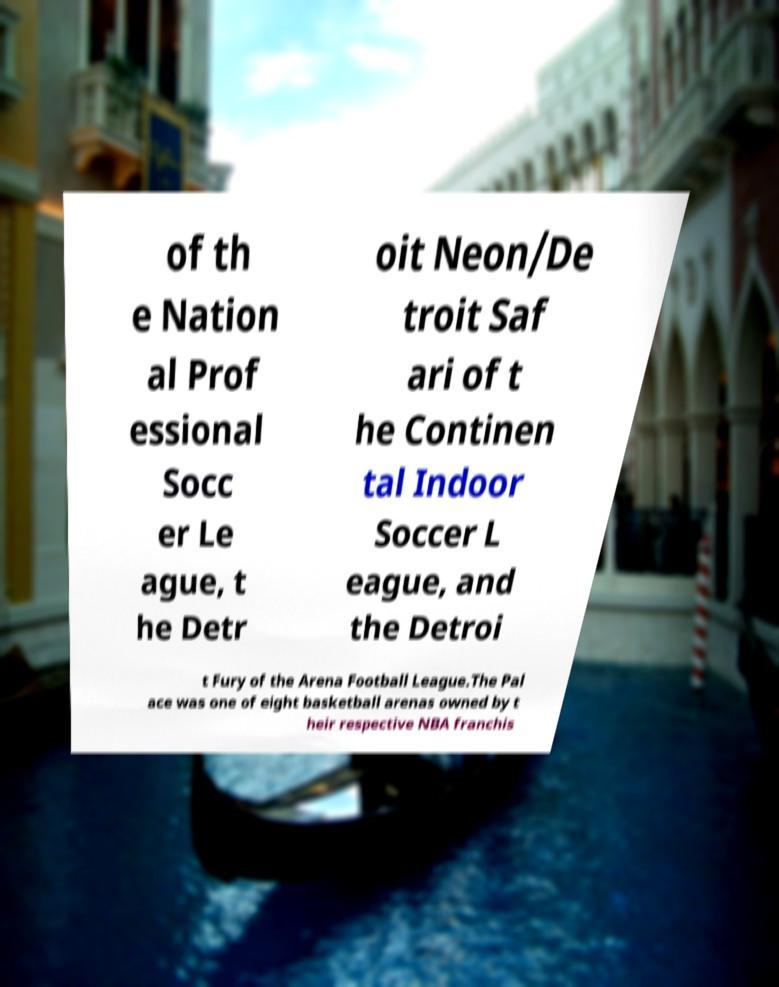Can you read and provide the text displayed in the image?This photo seems to have some interesting text. Can you extract and type it out for me? of th e Nation al Prof essional Socc er Le ague, t he Detr oit Neon/De troit Saf ari of t he Continen tal Indoor Soccer L eague, and the Detroi t Fury of the Arena Football League.The Pal ace was one of eight basketball arenas owned by t heir respective NBA franchis 